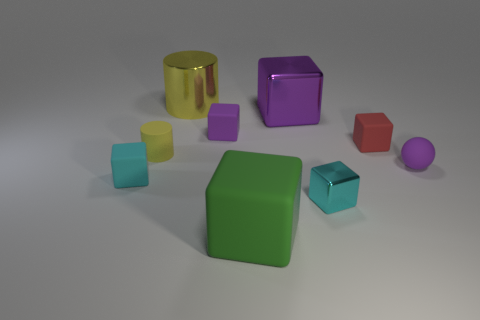What is the shape of the matte object that is the same color as the big cylinder?
Make the answer very short. Cylinder. How many purple objects have the same material as the big green object?
Make the answer very short. 2. The large matte cube is what color?
Offer a very short reply. Green. There is a matte sphere that is the same size as the cyan metallic thing; what color is it?
Your response must be concise. Purple. Is there another cube that has the same color as the small shiny block?
Provide a succinct answer. Yes. Do the large metal object that is to the right of the large yellow cylinder and the large object that is in front of the red cube have the same shape?
Ensure brevity in your answer.  Yes. There is a matte block that is the same color as the tiny ball; what is its size?
Give a very brief answer. Small. How many other objects are the same size as the purple matte sphere?
Your answer should be very brief. 5. There is a big metallic cube; is it the same color as the tiny matte ball right of the large purple object?
Keep it short and to the point. Yes. Is the number of purple shiny blocks that are to the left of the small purple rubber block less than the number of cylinders on the left side of the big cylinder?
Provide a short and direct response. Yes. 